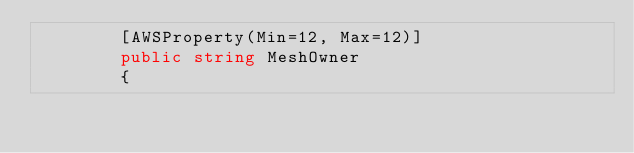<code> <loc_0><loc_0><loc_500><loc_500><_C#_>        [AWSProperty(Min=12, Max=12)]
        public string MeshOwner
        {</code> 